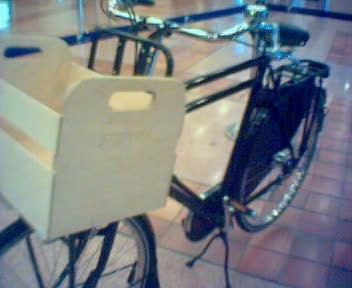Would there be a bicycle in the image if the bicycle was not in the picture? No 